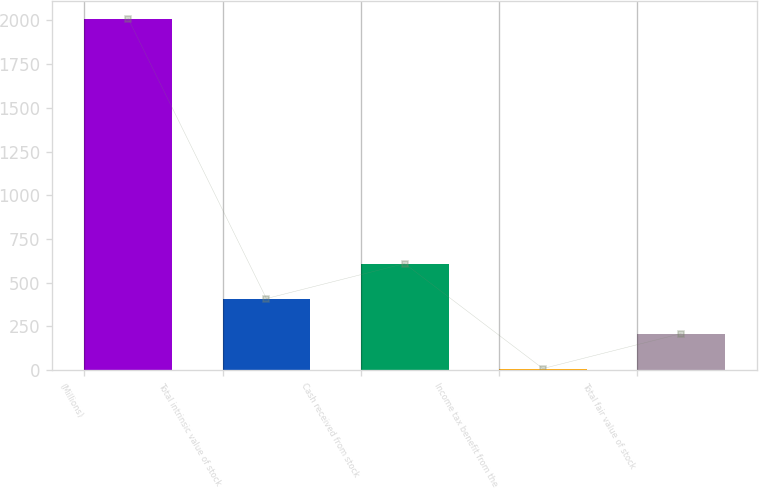Convert chart to OTSL. <chart><loc_0><loc_0><loc_500><loc_500><bar_chart><fcel>(Millions)<fcel>Total intrinsic value of stock<fcel>Cash received from stock<fcel>Income tax benefit from the<fcel>Total fair value of stock<nl><fcel>2010<fcel>409.2<fcel>609.3<fcel>9<fcel>209.1<nl></chart> 